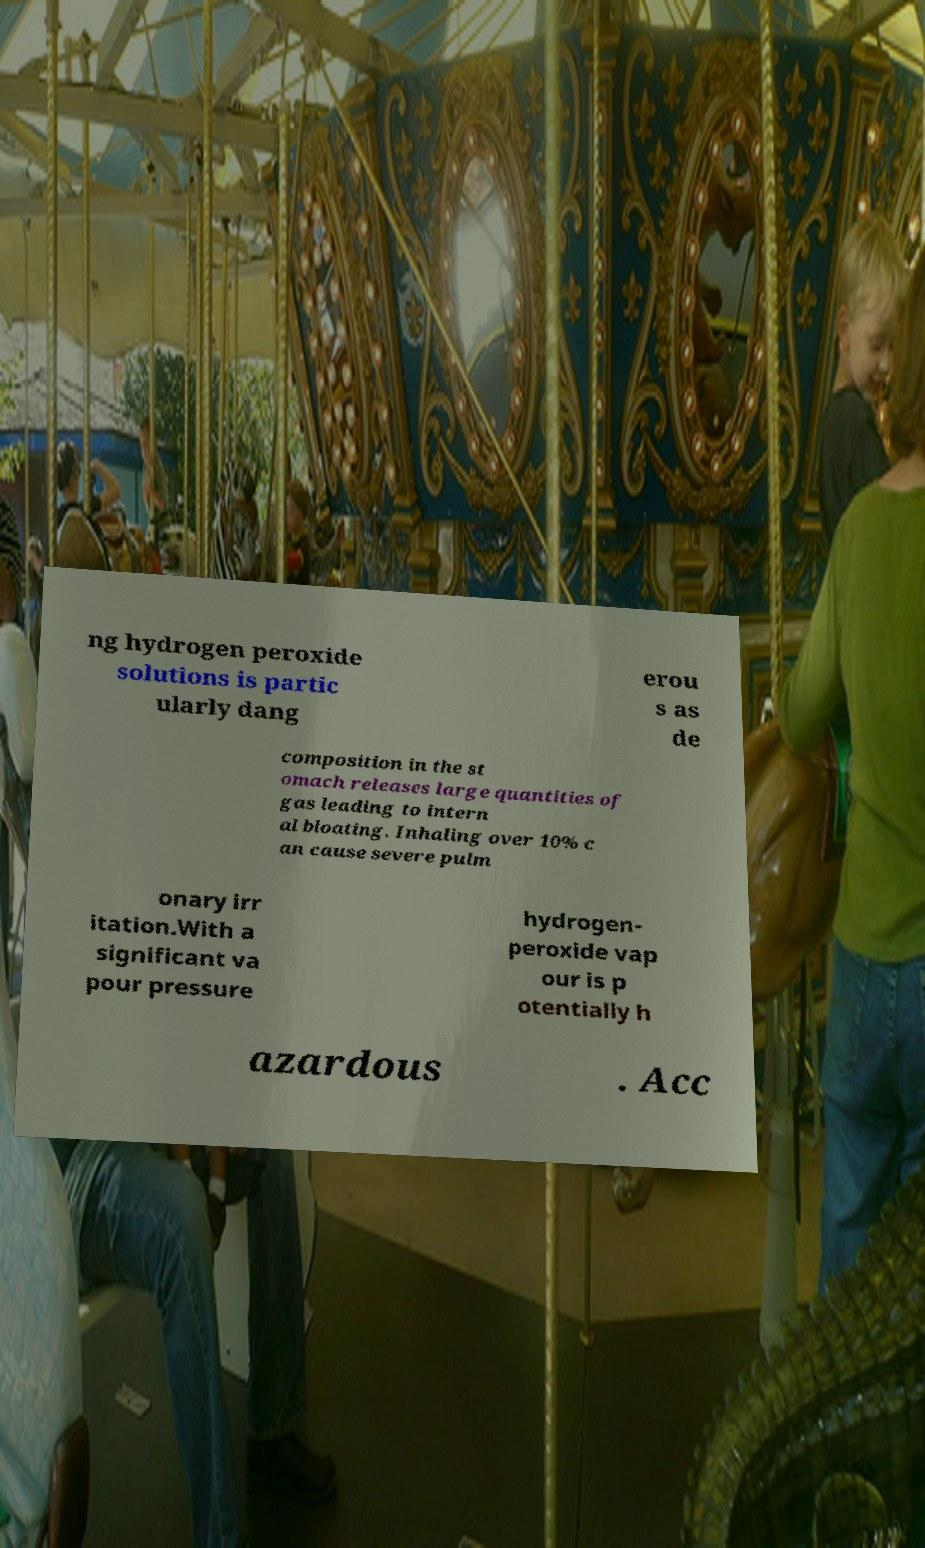Please read and relay the text visible in this image. What does it say? ng hydrogen peroxide solutions is partic ularly dang erou s as de composition in the st omach releases large quantities of gas leading to intern al bloating. Inhaling over 10% c an cause severe pulm onary irr itation.With a significant va pour pressure hydrogen- peroxide vap our is p otentially h azardous . Acc 